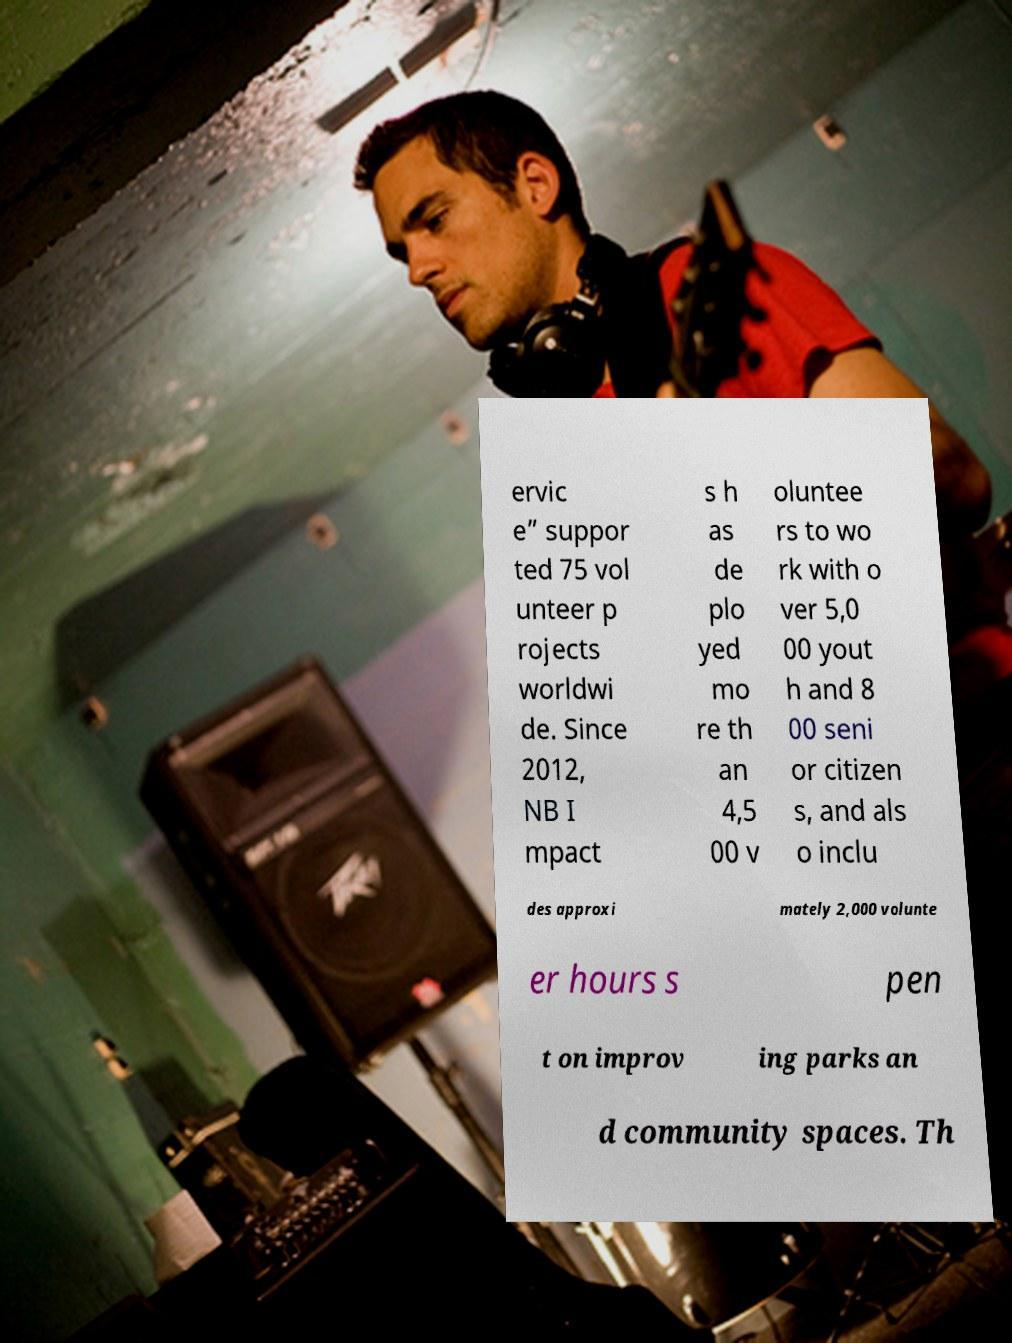What messages or text are displayed in this image? I need them in a readable, typed format. ervic e” suppor ted 75 vol unteer p rojects worldwi de. Since 2012, NB I mpact s h as de plo yed mo re th an 4,5 00 v oluntee rs to wo rk with o ver 5,0 00 yout h and 8 00 seni or citizen s, and als o inclu des approxi mately 2,000 volunte er hours s pen t on improv ing parks an d community spaces. Th 